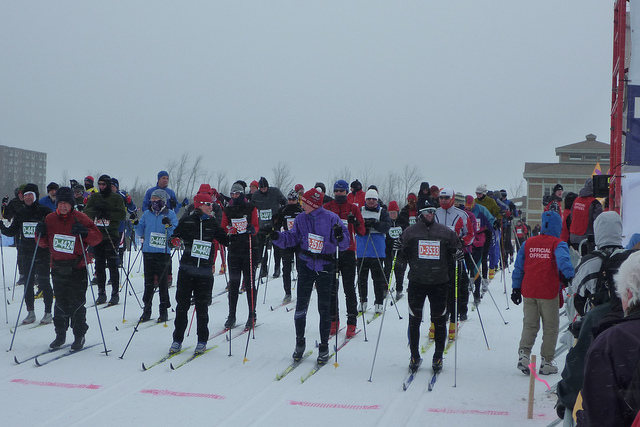<image>What water sport do they participate in? There is no water sport participation in the image. They seem to be involved in skiing. The people are having a what? I don't know what the people are having. It could be a race, competition, or a skiing contest. What number is this person wearing? I don't know what number the person is wearing. It can be any number such as '440', '20', '0 353', '442', '1483', '3533', '58', '3553' or '300'. The people are having a what? I am not sure what the people are having. It can be a race, competition, or skiing contest. What water sport do they participate in? I am not sure what water sport they participate in. It can be seen that they are skiing, but there is also a possibility of swimming. What number is this person wearing? I don't know what number this person is wearing. It could be any of the given options. 